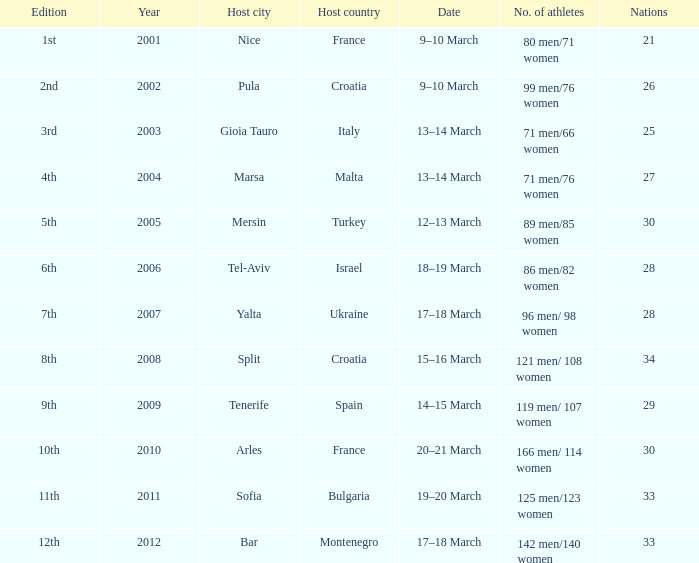In what year was Montenegro the host country? 2012.0. 